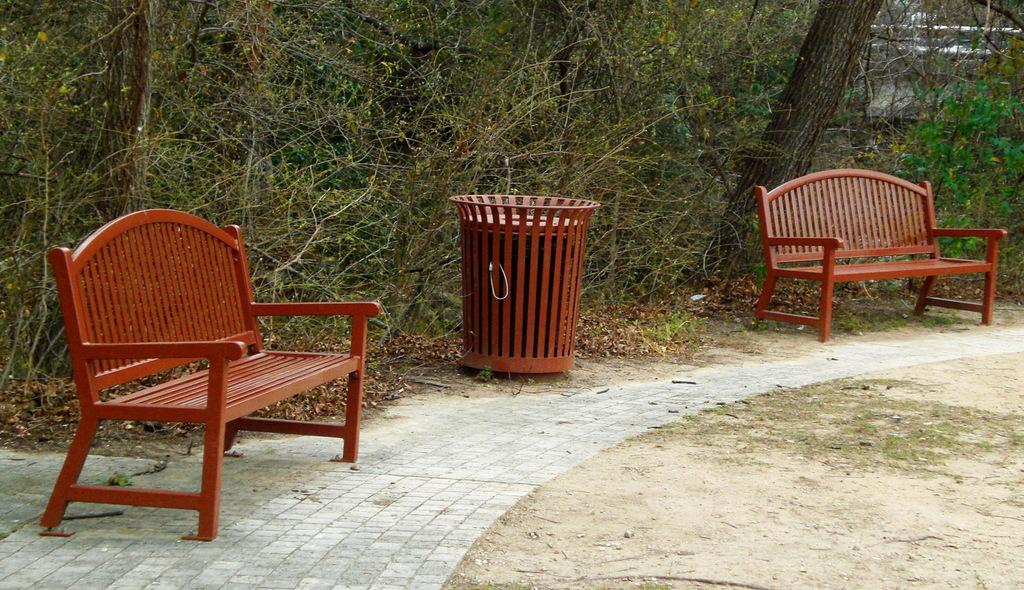How many chairs are visible in the image? There are two chairs in the image. What can be seen in the background of the image? There are trees in the background of the image. What type of fiction is being read by the stick in the image? There is no stick or any indication of reading in the image. 